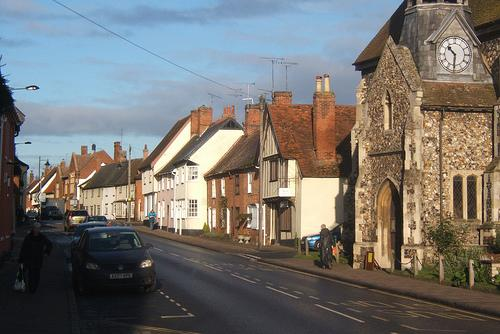What can you infer from the presence of the concrete flower pots in the image? The concrete flower pots may indicate that the image shows a residential or commercial area with an emphasis on aesthetics and landscaping. Comment on the quality of the image based on the objects and their details. The image quality seems to be quite good since the objects are clearly visible and detailed, which allows for a clear understanding of the scene. Why might the street light be an important object in this scene? The street light is important because it illuminates the area, ensuring safety and visibility for pedestrians and motorists at night. Examine the picture and identify the color of the cat sitting on the windowsill. There is no cat visible on any windowsill in the image. Please identify the type of flowers present in the flower pots and estimate the number of flowers in them. The image does not provide a clear view of the flower pots to determine the type of flowers or the number of flowers in them. Can you please check if there's a person holding an umbrella in the image? If yes, describe the umbrella's pattern. There is no person holding an umbrella visible in the image. Please look at the image and tell me if the hot air balloon in the sky is large or small. There is no hot air balloon visible in the sky in the image. 